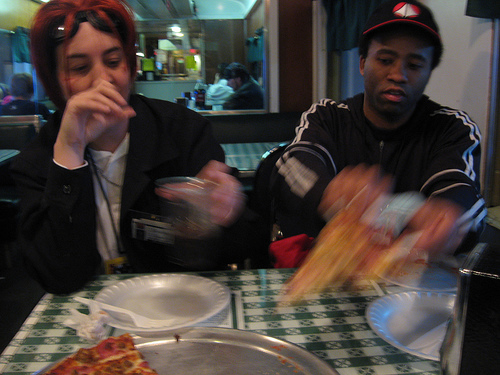<image>
Is there a hat above the head? Yes. The hat is positioned above the head in the vertical space, higher up in the scene. 